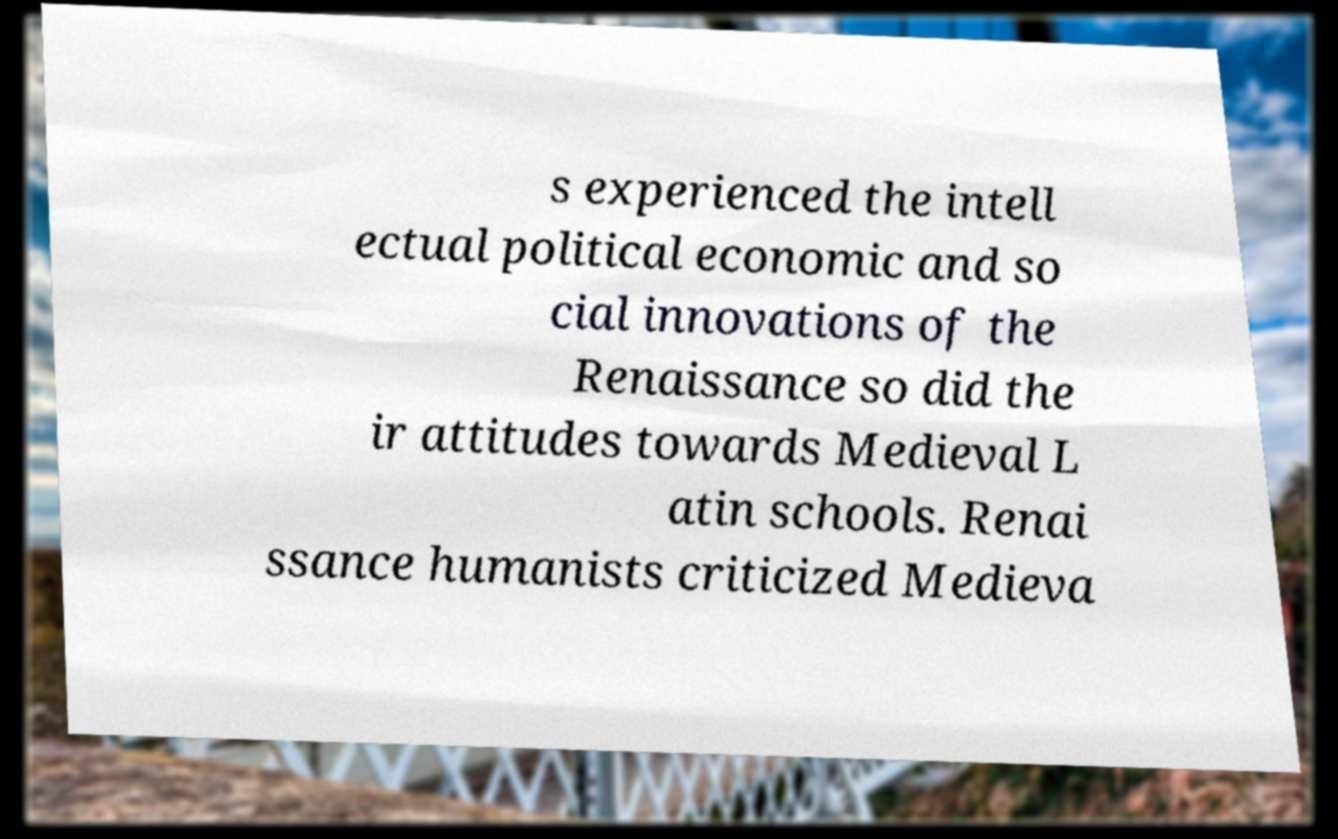Please identify and transcribe the text found in this image. s experienced the intell ectual political economic and so cial innovations of the Renaissance so did the ir attitudes towards Medieval L atin schools. Renai ssance humanists criticized Medieva 